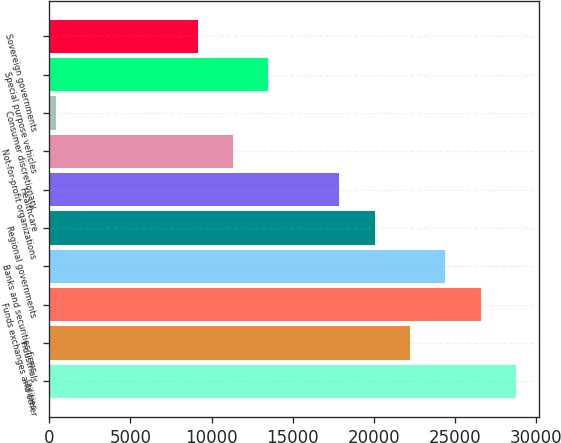Convert chart to OTSL. <chart><loc_0><loc_0><loc_500><loc_500><bar_chart><fcel>Utilities<fcel>Industrials<fcel>Funds exchanges and other<fcel>Banks and securities firms<fcel>Regional governments<fcel>Healthcare<fcel>Not-for-profit organizations<fcel>Consumer discretionary<fcel>Special purpose vehicles<fcel>Sovereign governments<nl><fcel>28768.2<fcel>22227<fcel>26587.8<fcel>24407.4<fcel>20046.6<fcel>17866.2<fcel>11325<fcel>423<fcel>13505.4<fcel>9144.6<nl></chart> 